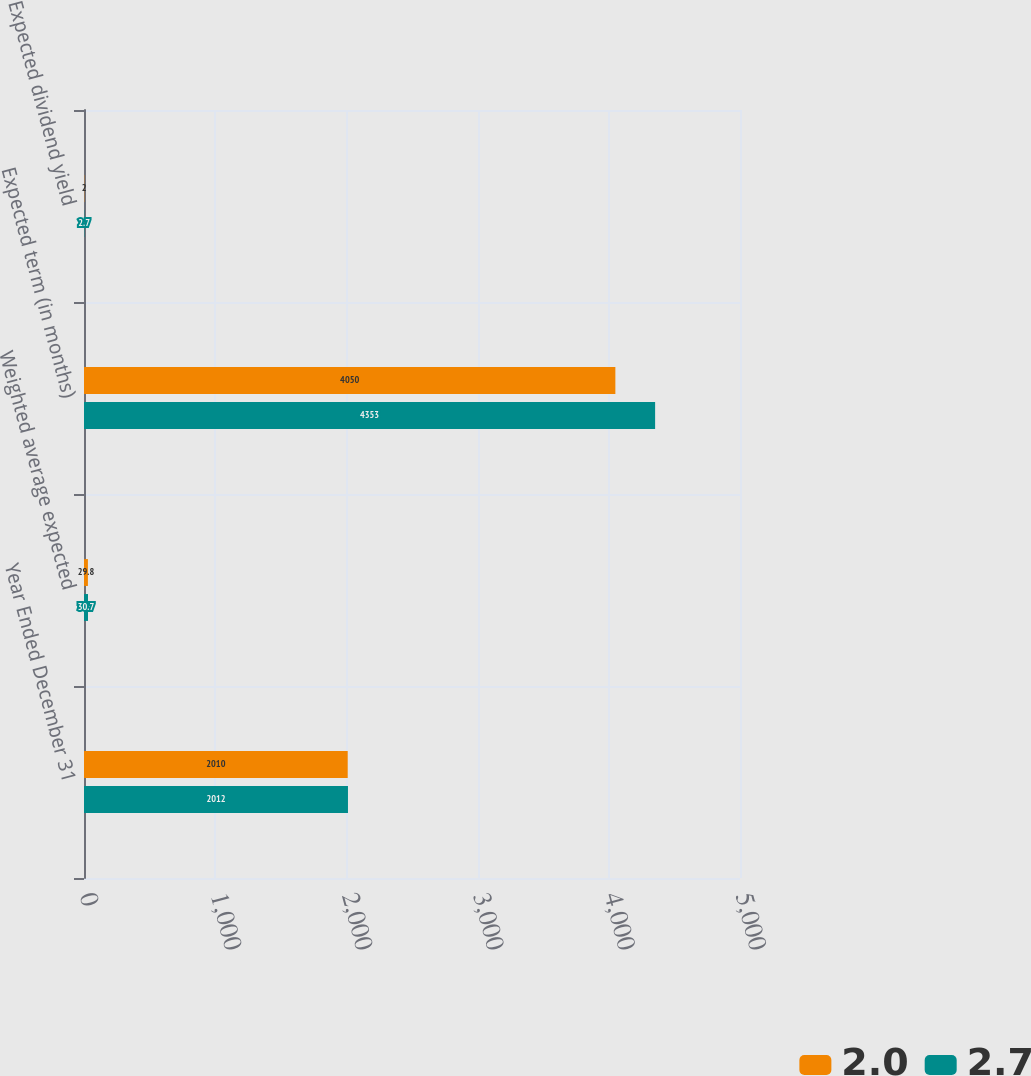Convert chart to OTSL. <chart><loc_0><loc_0><loc_500><loc_500><stacked_bar_chart><ecel><fcel>Year Ended December 31<fcel>Weighted average expected<fcel>Expected term (in months)<fcel>Expected dividend yield<nl><fcel>2<fcel>2010<fcel>29.8<fcel>4050<fcel>2<nl><fcel>2.7<fcel>2012<fcel>30.7<fcel>4353<fcel>2.7<nl></chart> 